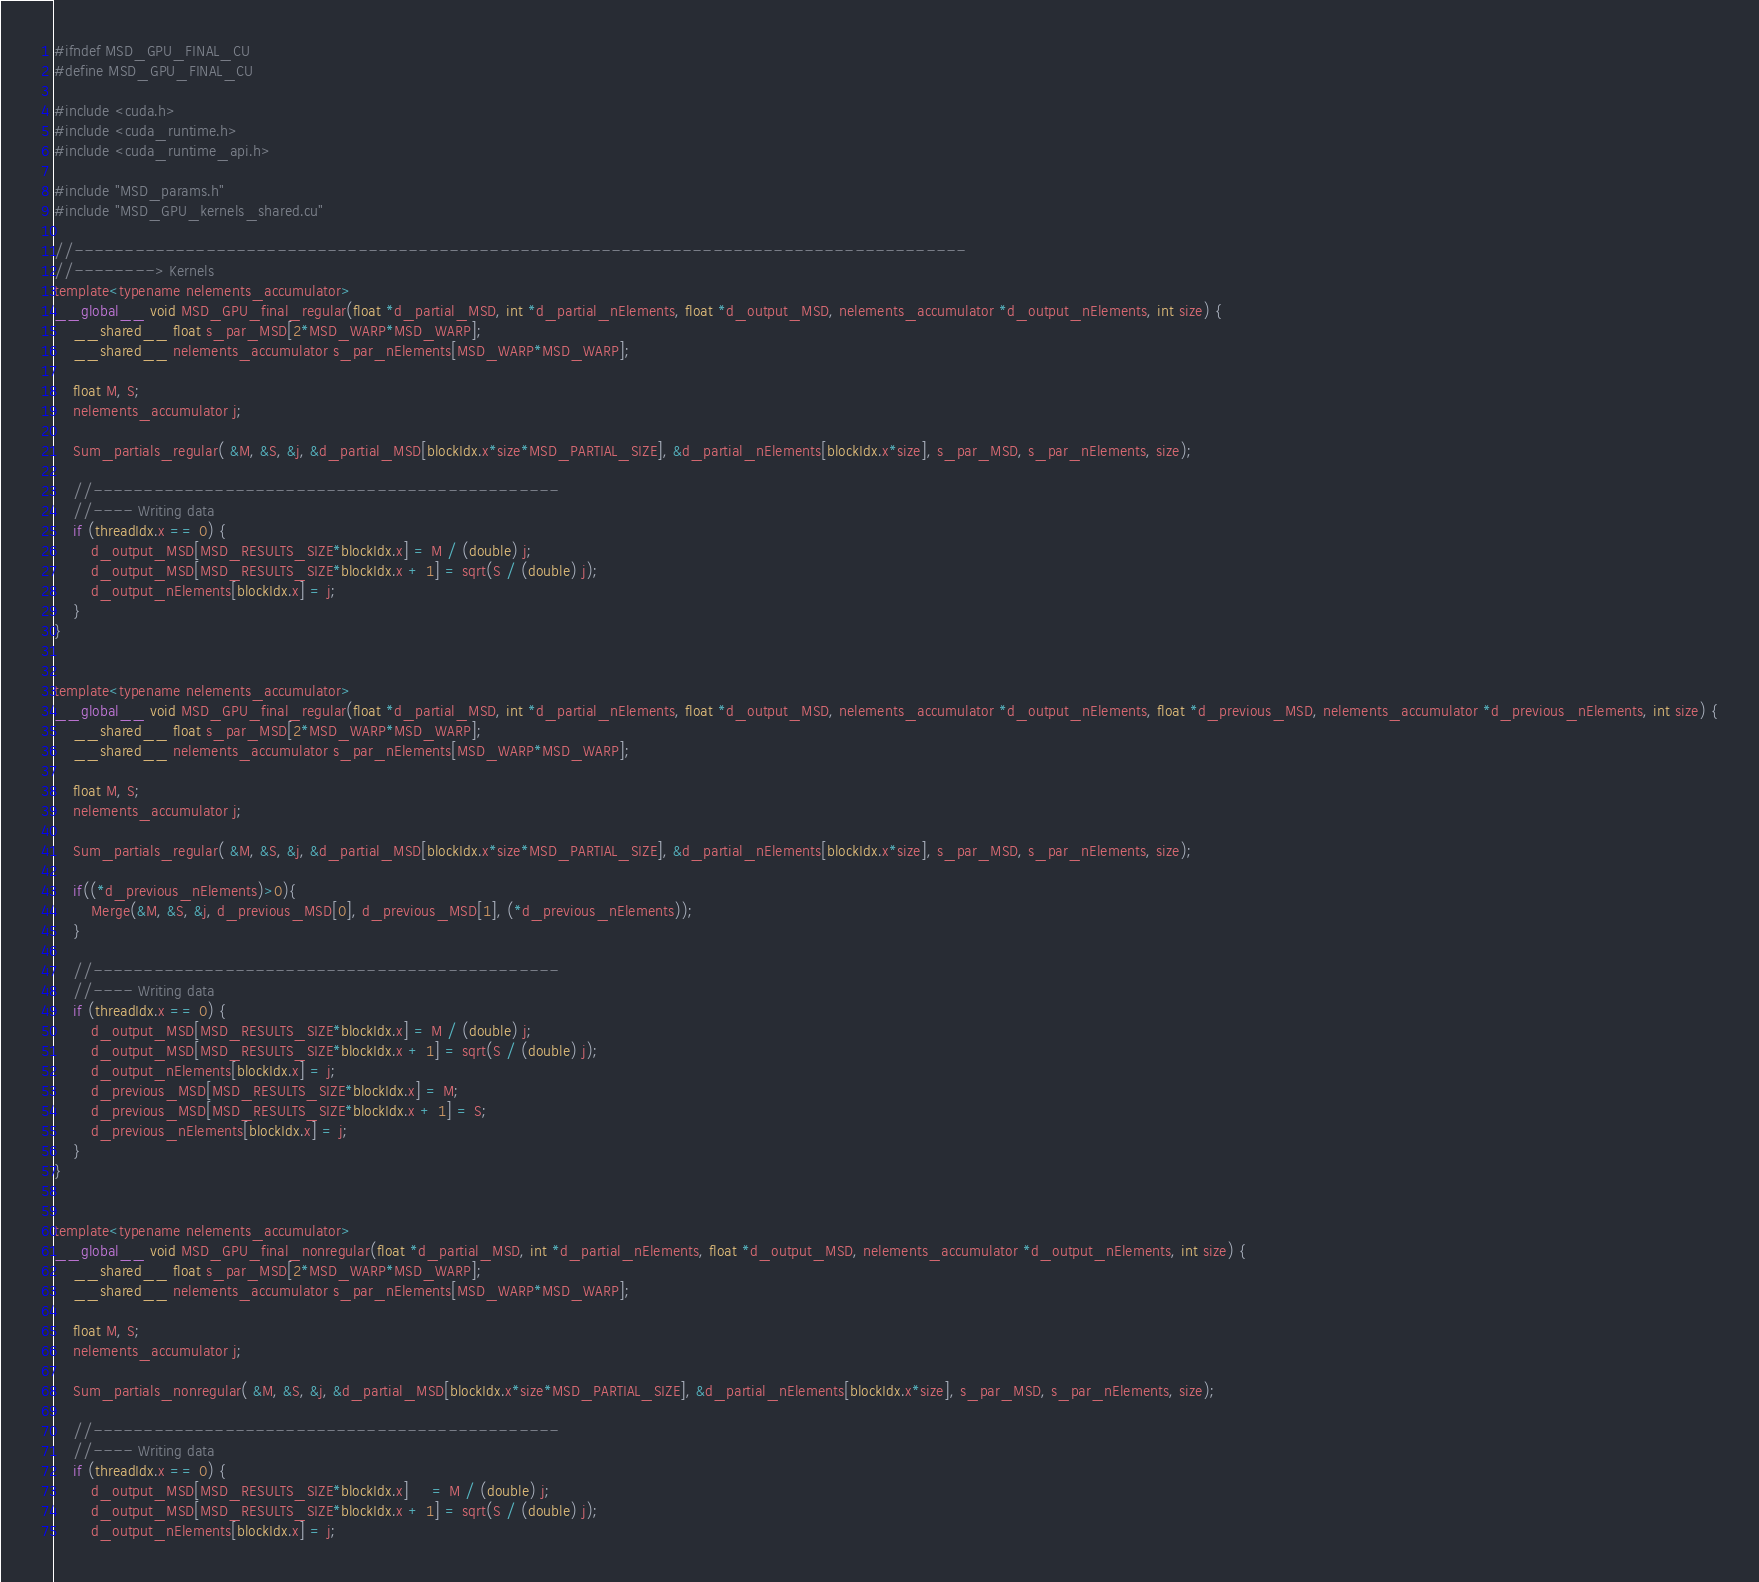Convert code to text. <code><loc_0><loc_0><loc_500><loc_500><_Cuda_>#ifndef MSD_GPU_FINAL_CU
#define MSD_GPU_FINAL_CU

#include <cuda.h>
#include <cuda_runtime.h>
#include <cuda_runtime_api.h>

#include "MSD_params.h"
#include "MSD_GPU_kernels_shared.cu"

//----------------------------------------------------------------------------------------
//--------> Kernels
template<typename nelements_accumulator>
__global__ void MSD_GPU_final_regular(float *d_partial_MSD, int *d_partial_nElements, float *d_output_MSD, nelements_accumulator *d_output_nElements, int size) {
	__shared__ float s_par_MSD[2*MSD_WARP*MSD_WARP];
	__shared__ nelements_accumulator s_par_nElements[MSD_WARP*MSD_WARP];

	float M, S;
	nelements_accumulator j;
	
	Sum_partials_regular( &M, &S, &j, &d_partial_MSD[blockIdx.x*size*MSD_PARTIAL_SIZE], &d_partial_nElements[blockIdx.x*size], s_par_MSD, s_par_nElements, size);

	//----------------------------------------------
	//---- Writing data
	if (threadIdx.x == 0) {
		d_output_MSD[MSD_RESULTS_SIZE*blockIdx.x] = M / (double) j;
		d_output_MSD[MSD_RESULTS_SIZE*blockIdx.x + 1] = sqrt(S / (double) j);
		d_output_nElements[blockIdx.x] = j;
	}
}


template<typename nelements_accumulator>
__global__ void MSD_GPU_final_regular(float *d_partial_MSD, int *d_partial_nElements, float *d_output_MSD, nelements_accumulator *d_output_nElements, float *d_previous_MSD, nelements_accumulator *d_previous_nElements, int size) {
	__shared__ float s_par_MSD[2*MSD_WARP*MSD_WARP];
	__shared__ nelements_accumulator s_par_nElements[MSD_WARP*MSD_WARP];

	float M, S;
	nelements_accumulator j;
	
	Sum_partials_regular( &M, &S, &j, &d_partial_MSD[blockIdx.x*size*MSD_PARTIAL_SIZE], &d_partial_nElements[blockIdx.x*size], s_par_MSD, s_par_nElements, size);

	if((*d_previous_nElements)>0){
		Merge(&M, &S, &j, d_previous_MSD[0], d_previous_MSD[1], (*d_previous_nElements));
	}
	
	//----------------------------------------------
	//---- Writing data
	if (threadIdx.x == 0) {
		d_output_MSD[MSD_RESULTS_SIZE*blockIdx.x] = M / (double) j;
		d_output_MSD[MSD_RESULTS_SIZE*blockIdx.x + 1] = sqrt(S / (double) j);
		d_output_nElements[blockIdx.x] = j;
		d_previous_MSD[MSD_RESULTS_SIZE*blockIdx.x] = M;
		d_previous_MSD[MSD_RESULTS_SIZE*blockIdx.x + 1] = S;
		d_previous_nElements[blockIdx.x] = j;
	}
}


template<typename nelements_accumulator>
__global__ void MSD_GPU_final_nonregular(float *d_partial_MSD, int *d_partial_nElements, float *d_output_MSD, nelements_accumulator *d_output_nElements, int size) {
	__shared__ float s_par_MSD[2*MSD_WARP*MSD_WARP];
	__shared__ nelements_accumulator s_par_nElements[MSD_WARP*MSD_WARP];
	
	float M, S;
	nelements_accumulator j;

	Sum_partials_nonregular( &M, &S, &j, &d_partial_MSD[blockIdx.x*size*MSD_PARTIAL_SIZE], &d_partial_nElements[blockIdx.x*size], s_par_MSD, s_par_nElements, size);
	
	//----------------------------------------------
	//---- Writing data
	if (threadIdx.x == 0) {
		d_output_MSD[MSD_RESULTS_SIZE*blockIdx.x]     = M / (double) j;
		d_output_MSD[MSD_RESULTS_SIZE*blockIdx.x + 1] = sqrt(S / (double) j);
		d_output_nElements[blockIdx.x] = j;</code> 